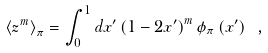<formula> <loc_0><loc_0><loc_500><loc_500>\left \langle z ^ { m } \right \rangle _ { \pi } = \int _ { 0 } ^ { 1 } d x ^ { \prime } \left ( 1 - 2 x ^ { \prime } \right ) ^ { m } \phi _ { \pi } \left ( x ^ { \prime } \right ) \ ,</formula> 